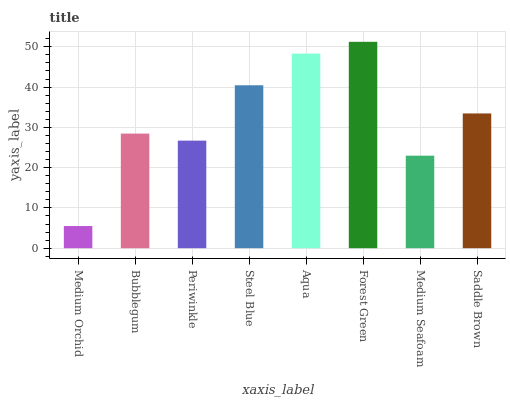Is Medium Orchid the minimum?
Answer yes or no. Yes. Is Forest Green the maximum?
Answer yes or no. Yes. Is Bubblegum the minimum?
Answer yes or no. No. Is Bubblegum the maximum?
Answer yes or no. No. Is Bubblegum greater than Medium Orchid?
Answer yes or no. Yes. Is Medium Orchid less than Bubblegum?
Answer yes or no. Yes. Is Medium Orchid greater than Bubblegum?
Answer yes or no. No. Is Bubblegum less than Medium Orchid?
Answer yes or no. No. Is Saddle Brown the high median?
Answer yes or no. Yes. Is Bubblegum the low median?
Answer yes or no. Yes. Is Periwinkle the high median?
Answer yes or no. No. Is Medium Orchid the low median?
Answer yes or no. No. 